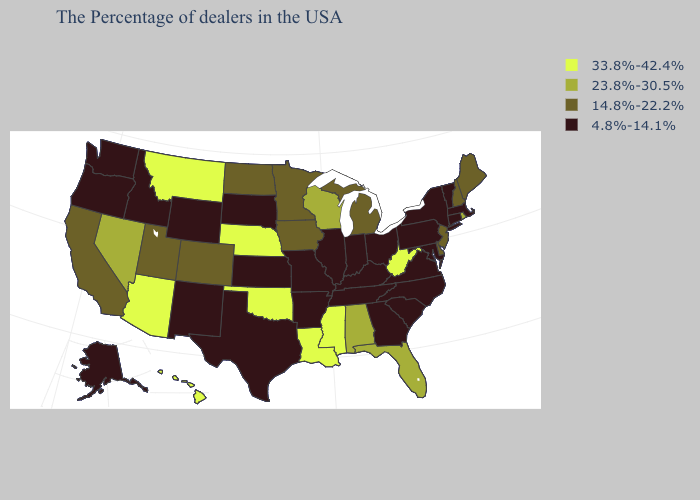What is the value of Kansas?
Write a very short answer. 4.8%-14.1%. Does the map have missing data?
Concise answer only. No. Among the states that border Idaho , does Nevada have the lowest value?
Answer briefly. No. Does the first symbol in the legend represent the smallest category?
Quick response, please. No. Name the states that have a value in the range 14.8%-22.2%?
Answer briefly. Maine, New Hampshire, New Jersey, Delaware, Michigan, Minnesota, Iowa, North Dakota, Colorado, Utah, California. What is the value of South Dakota?
Give a very brief answer. 4.8%-14.1%. Among the states that border Minnesota , which have the highest value?
Answer briefly. Wisconsin. Name the states that have a value in the range 4.8%-14.1%?
Be succinct. Massachusetts, Vermont, Connecticut, New York, Maryland, Pennsylvania, Virginia, North Carolina, South Carolina, Ohio, Georgia, Kentucky, Indiana, Tennessee, Illinois, Missouri, Arkansas, Kansas, Texas, South Dakota, Wyoming, New Mexico, Idaho, Washington, Oregon, Alaska. Does the map have missing data?
Short answer required. No. What is the highest value in the USA?
Give a very brief answer. 33.8%-42.4%. What is the value of Oklahoma?
Be succinct. 33.8%-42.4%. Among the states that border Delaware , does Maryland have the lowest value?
Be succinct. Yes. Which states have the lowest value in the West?
Short answer required. Wyoming, New Mexico, Idaho, Washington, Oregon, Alaska. Among the states that border Michigan , which have the highest value?
Give a very brief answer. Wisconsin. What is the lowest value in the USA?
Short answer required. 4.8%-14.1%. 